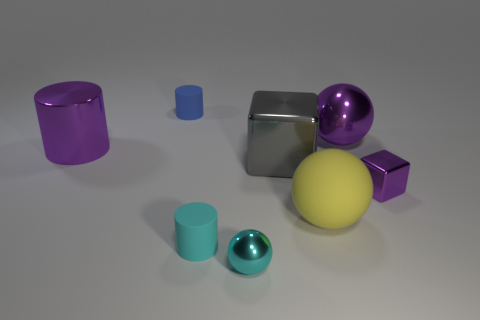There is a gray metal object that is the same size as the purple metal sphere; what shape is it?
Your response must be concise. Cube. Is the number of large gray shiny objects less than the number of rubber cylinders?
Provide a succinct answer. Yes. Is there a blue rubber cylinder on the right side of the small object that is on the right side of the small cyan sphere?
Provide a short and direct response. No. There is a cyan thing that is the same material as the small purple thing; what shape is it?
Provide a short and direct response. Sphere. Is there anything else of the same color as the small metal cube?
Offer a very short reply. Yes. There is a cyan thing that is the same shape as the blue object; what is it made of?
Ensure brevity in your answer.  Rubber. How many other objects are there of the same size as the purple cube?
Your answer should be very brief. 3. What is the size of the metal block that is the same color as the large cylinder?
Keep it short and to the point. Small. Do the big purple metal object on the right side of the big matte thing and the big gray thing have the same shape?
Provide a succinct answer. No. How many other objects are there of the same shape as the tiny purple thing?
Your response must be concise. 1. 